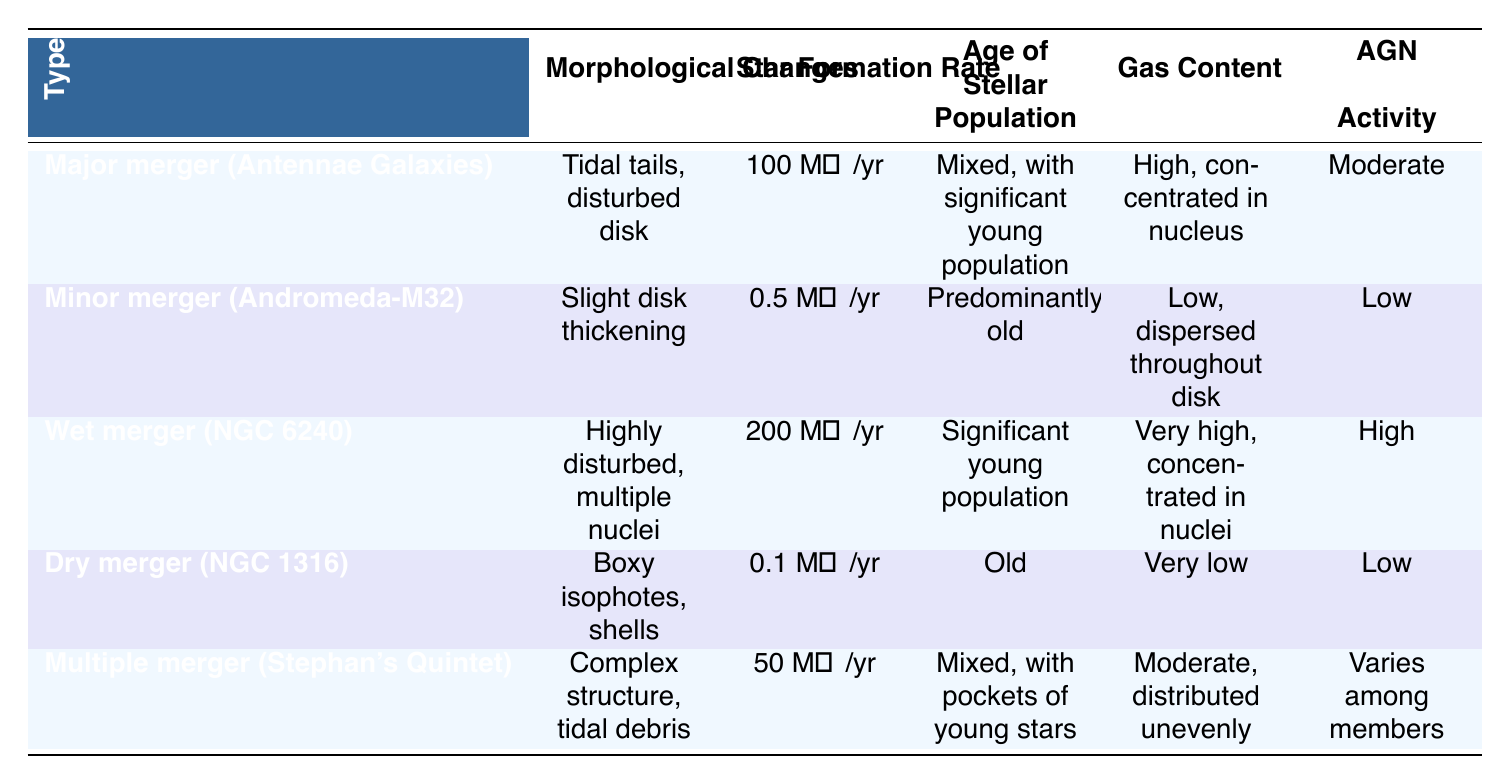What is the star formation rate for the Wet merger (NGC 6240)? The table specifies that the star formation rate for the Wet merger (NGC 6240) is given directly in the corresponding row.
Answer: 200 M☉/yr How does the gas content of the Major merger (Antennae Galaxies) compare to that of the Dry merger (NGC 1316)? In the table, the gas content of the Major merger is high and concentrated in the nucleus, while for the Dry merger, it is very low. This indicates a significant difference in gas content.
Answer: Major merger has high gas content; Dry merger has very low gas content Is the star formation rate of the Minor merger (Andromeda-M32) greater than that of the Multiple merger (Stephan's Quintet)? The Minor merger has a star formation rate of 0.5 M☉/yr, while the Multiple merger has a star formation rate of 50 M☉/yr, so the statement is false.
Answer: No What is the most significant morphological change observed in a Wet merger? According to the table, the Wet merger (NGC 6240) shows highly disturbed morphology with multiple nuclei, which is the most significant change listed for this type of merger.
Answer: Highly disturbed, multiple nuclei If we average the star formation rates of all the mergers, what value do we get? We first sum the star formation rates: 100 + 0.5 + 200 + 0.1 + 50 = 350 M☉/yr. There are 5 merger types, so we divide the total by 5: 350/5 = 70 M☉/yr.
Answer: 70 M☉/yr Does the presence of an Active Galactic Nucleus (AGN) exhibit any pattern across the different merger types? By examining the table, we can see that the AGN activity varies based on the merger type — it's moderate in Major merger, low in Minor and Dry mergers, high in Wet merger, and varies in Multiple merger. Thus, there is a noticeable pattern of AGN activity related to merger types.
Answer: Yes, there is a pattern Which merger type has the highest star formation rate and what is it? The Wet merger (NGC 6240) has the highest star formation rate of 200 M☉/yr, as indicated in the star formation rate column.
Answer: Wet merger (NGC 6240); 200 M☉/yr In which merger type is the age of the stellar population classified as predominantly old? Looking at the table, the Minor merger (Andromeda-M32) is stated to have a predominantly old stellar population.
Answer: Minor merger (Andromeda-M32) What trend can be seen between the age of the stellar population and the star formation rate for the Dry merger (NGC 1316)? The Dry merger has an old stellar population and a low star formation rate of 0.1 M☉/yr, indicating an inverse trend; as the age of stars increases, star formation rate decreases.
Answer: Inverse trend; older population correlates with lower star formation rate 